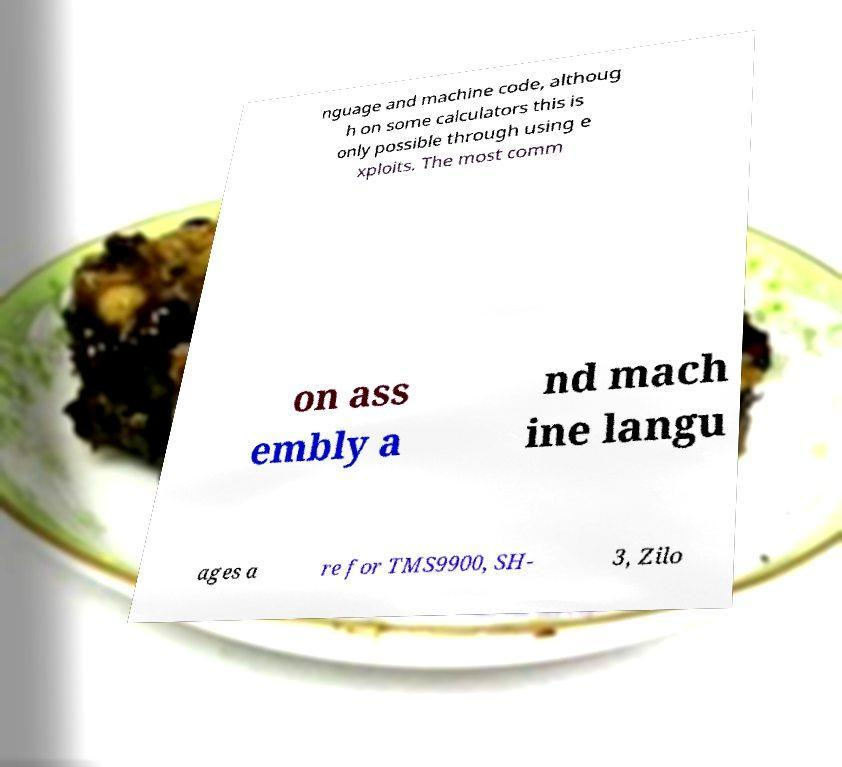Please read and relay the text visible in this image. What does it say? nguage and machine code, althoug h on some calculators this is only possible through using e xploits. The most comm on ass embly a nd mach ine langu ages a re for TMS9900, SH- 3, Zilo 